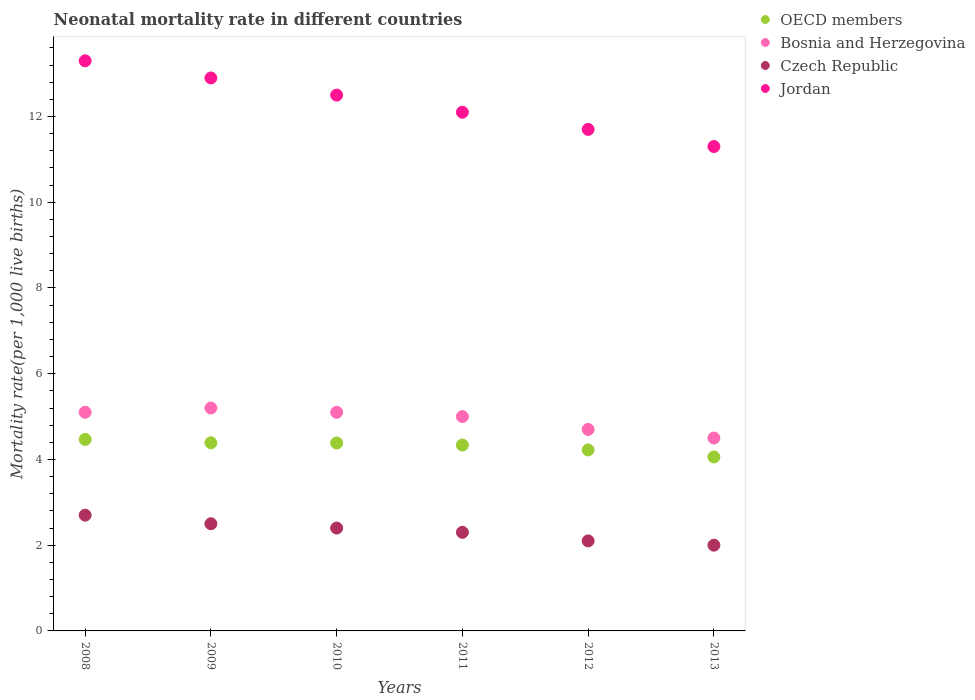How many different coloured dotlines are there?
Offer a terse response. 4. Is the number of dotlines equal to the number of legend labels?
Keep it short and to the point. Yes. What is the neonatal mortality rate in OECD members in 2009?
Offer a terse response. 4.39. Across all years, what is the maximum neonatal mortality rate in Bosnia and Herzegovina?
Ensure brevity in your answer.  5.2. In which year was the neonatal mortality rate in Jordan maximum?
Your answer should be compact. 2008. In which year was the neonatal mortality rate in Jordan minimum?
Make the answer very short. 2013. What is the total neonatal mortality rate in Jordan in the graph?
Your answer should be compact. 73.8. What is the difference between the neonatal mortality rate in Czech Republic in 2008 and that in 2012?
Ensure brevity in your answer.  0.6. What is the difference between the neonatal mortality rate in Jordan in 2011 and the neonatal mortality rate in Czech Republic in 2013?
Keep it short and to the point. 10.1. What is the average neonatal mortality rate in Jordan per year?
Offer a terse response. 12.3. In the year 2013, what is the difference between the neonatal mortality rate in OECD members and neonatal mortality rate in Czech Republic?
Provide a succinct answer. 2.06. In how many years, is the neonatal mortality rate in Czech Republic greater than 12?
Provide a succinct answer. 0. What is the ratio of the neonatal mortality rate in Jordan in 2009 to that in 2013?
Your response must be concise. 1.14. What is the difference between the highest and the second highest neonatal mortality rate in Czech Republic?
Provide a short and direct response. 0.2. In how many years, is the neonatal mortality rate in Bosnia and Herzegovina greater than the average neonatal mortality rate in Bosnia and Herzegovina taken over all years?
Give a very brief answer. 4. Is the sum of the neonatal mortality rate in Czech Republic in 2011 and 2012 greater than the maximum neonatal mortality rate in Bosnia and Herzegovina across all years?
Provide a succinct answer. No. Is it the case that in every year, the sum of the neonatal mortality rate in Bosnia and Herzegovina and neonatal mortality rate in Jordan  is greater than the neonatal mortality rate in Czech Republic?
Your answer should be compact. Yes. Does the neonatal mortality rate in Bosnia and Herzegovina monotonically increase over the years?
Offer a very short reply. No. Is the neonatal mortality rate in Bosnia and Herzegovina strictly less than the neonatal mortality rate in Jordan over the years?
Offer a very short reply. Yes. How many dotlines are there?
Provide a succinct answer. 4. How many years are there in the graph?
Your answer should be compact. 6. What is the difference between two consecutive major ticks on the Y-axis?
Keep it short and to the point. 2. Are the values on the major ticks of Y-axis written in scientific E-notation?
Your answer should be compact. No. Where does the legend appear in the graph?
Provide a succinct answer. Top right. How many legend labels are there?
Ensure brevity in your answer.  4. What is the title of the graph?
Offer a very short reply. Neonatal mortality rate in different countries. Does "Turks and Caicos Islands" appear as one of the legend labels in the graph?
Keep it short and to the point. No. What is the label or title of the Y-axis?
Make the answer very short. Mortality rate(per 1,0 live births). What is the Mortality rate(per 1,000 live births) in OECD members in 2008?
Provide a short and direct response. 4.47. What is the Mortality rate(per 1,000 live births) in Bosnia and Herzegovina in 2008?
Your answer should be compact. 5.1. What is the Mortality rate(per 1,000 live births) of OECD members in 2009?
Your response must be concise. 4.39. What is the Mortality rate(per 1,000 live births) of Bosnia and Herzegovina in 2009?
Offer a terse response. 5.2. What is the Mortality rate(per 1,000 live births) of Czech Republic in 2009?
Your answer should be very brief. 2.5. What is the Mortality rate(per 1,000 live births) in Jordan in 2009?
Keep it short and to the point. 12.9. What is the Mortality rate(per 1,000 live births) in OECD members in 2010?
Provide a short and direct response. 4.38. What is the Mortality rate(per 1,000 live births) in Bosnia and Herzegovina in 2010?
Offer a terse response. 5.1. What is the Mortality rate(per 1,000 live births) in Czech Republic in 2010?
Offer a terse response. 2.4. What is the Mortality rate(per 1,000 live births) in OECD members in 2011?
Your answer should be compact. 4.34. What is the Mortality rate(per 1,000 live births) in Czech Republic in 2011?
Your answer should be very brief. 2.3. What is the Mortality rate(per 1,000 live births) of Jordan in 2011?
Provide a succinct answer. 12.1. What is the Mortality rate(per 1,000 live births) in OECD members in 2012?
Offer a very short reply. 4.22. What is the Mortality rate(per 1,000 live births) in Bosnia and Herzegovina in 2012?
Offer a terse response. 4.7. What is the Mortality rate(per 1,000 live births) of Czech Republic in 2012?
Your answer should be very brief. 2.1. What is the Mortality rate(per 1,000 live births) of Jordan in 2012?
Provide a succinct answer. 11.7. What is the Mortality rate(per 1,000 live births) of OECD members in 2013?
Keep it short and to the point. 4.06. What is the Mortality rate(per 1,000 live births) in Bosnia and Herzegovina in 2013?
Ensure brevity in your answer.  4.5. What is the Mortality rate(per 1,000 live births) in Czech Republic in 2013?
Ensure brevity in your answer.  2. Across all years, what is the maximum Mortality rate(per 1,000 live births) in OECD members?
Your response must be concise. 4.47. Across all years, what is the minimum Mortality rate(per 1,000 live births) in OECD members?
Offer a terse response. 4.06. Across all years, what is the minimum Mortality rate(per 1,000 live births) in Bosnia and Herzegovina?
Offer a very short reply. 4.5. Across all years, what is the minimum Mortality rate(per 1,000 live births) of Czech Republic?
Offer a very short reply. 2. What is the total Mortality rate(per 1,000 live births) in OECD members in the graph?
Your answer should be very brief. 25.86. What is the total Mortality rate(per 1,000 live births) in Bosnia and Herzegovina in the graph?
Ensure brevity in your answer.  29.6. What is the total Mortality rate(per 1,000 live births) of Jordan in the graph?
Keep it short and to the point. 73.8. What is the difference between the Mortality rate(per 1,000 live births) of OECD members in 2008 and that in 2009?
Provide a succinct answer. 0.08. What is the difference between the Mortality rate(per 1,000 live births) in Bosnia and Herzegovina in 2008 and that in 2009?
Your answer should be compact. -0.1. What is the difference between the Mortality rate(per 1,000 live births) of Jordan in 2008 and that in 2009?
Give a very brief answer. 0.4. What is the difference between the Mortality rate(per 1,000 live births) of OECD members in 2008 and that in 2010?
Your answer should be very brief. 0.08. What is the difference between the Mortality rate(per 1,000 live births) in Bosnia and Herzegovina in 2008 and that in 2010?
Offer a terse response. 0. What is the difference between the Mortality rate(per 1,000 live births) in Czech Republic in 2008 and that in 2010?
Your answer should be very brief. 0.3. What is the difference between the Mortality rate(per 1,000 live births) of Jordan in 2008 and that in 2010?
Provide a succinct answer. 0.8. What is the difference between the Mortality rate(per 1,000 live births) in OECD members in 2008 and that in 2011?
Ensure brevity in your answer.  0.13. What is the difference between the Mortality rate(per 1,000 live births) in Bosnia and Herzegovina in 2008 and that in 2011?
Your response must be concise. 0.1. What is the difference between the Mortality rate(per 1,000 live births) in Czech Republic in 2008 and that in 2011?
Give a very brief answer. 0.4. What is the difference between the Mortality rate(per 1,000 live births) of OECD members in 2008 and that in 2012?
Keep it short and to the point. 0.25. What is the difference between the Mortality rate(per 1,000 live births) in Czech Republic in 2008 and that in 2012?
Your answer should be very brief. 0.6. What is the difference between the Mortality rate(per 1,000 live births) in OECD members in 2008 and that in 2013?
Make the answer very short. 0.41. What is the difference between the Mortality rate(per 1,000 live births) in Bosnia and Herzegovina in 2008 and that in 2013?
Ensure brevity in your answer.  0.6. What is the difference between the Mortality rate(per 1,000 live births) of Czech Republic in 2008 and that in 2013?
Give a very brief answer. 0.7. What is the difference between the Mortality rate(per 1,000 live births) in OECD members in 2009 and that in 2010?
Ensure brevity in your answer.  0. What is the difference between the Mortality rate(per 1,000 live births) of Jordan in 2009 and that in 2010?
Your answer should be very brief. 0.4. What is the difference between the Mortality rate(per 1,000 live births) of OECD members in 2009 and that in 2011?
Your response must be concise. 0.05. What is the difference between the Mortality rate(per 1,000 live births) of Czech Republic in 2009 and that in 2011?
Offer a terse response. 0.2. What is the difference between the Mortality rate(per 1,000 live births) of Jordan in 2009 and that in 2011?
Your answer should be very brief. 0.8. What is the difference between the Mortality rate(per 1,000 live births) of OECD members in 2009 and that in 2012?
Give a very brief answer. 0.17. What is the difference between the Mortality rate(per 1,000 live births) of Bosnia and Herzegovina in 2009 and that in 2012?
Give a very brief answer. 0.5. What is the difference between the Mortality rate(per 1,000 live births) in Jordan in 2009 and that in 2012?
Offer a very short reply. 1.2. What is the difference between the Mortality rate(per 1,000 live births) of OECD members in 2009 and that in 2013?
Give a very brief answer. 0.33. What is the difference between the Mortality rate(per 1,000 live births) in Bosnia and Herzegovina in 2009 and that in 2013?
Keep it short and to the point. 0.7. What is the difference between the Mortality rate(per 1,000 live births) in Jordan in 2009 and that in 2013?
Provide a short and direct response. 1.6. What is the difference between the Mortality rate(per 1,000 live births) of OECD members in 2010 and that in 2011?
Keep it short and to the point. 0.05. What is the difference between the Mortality rate(per 1,000 live births) of Czech Republic in 2010 and that in 2011?
Make the answer very short. 0.1. What is the difference between the Mortality rate(per 1,000 live births) in Jordan in 2010 and that in 2011?
Provide a short and direct response. 0.4. What is the difference between the Mortality rate(per 1,000 live births) of OECD members in 2010 and that in 2012?
Your response must be concise. 0.16. What is the difference between the Mortality rate(per 1,000 live births) in OECD members in 2010 and that in 2013?
Offer a very short reply. 0.33. What is the difference between the Mortality rate(per 1,000 live births) in Bosnia and Herzegovina in 2010 and that in 2013?
Provide a short and direct response. 0.6. What is the difference between the Mortality rate(per 1,000 live births) of Jordan in 2010 and that in 2013?
Your response must be concise. 1.2. What is the difference between the Mortality rate(per 1,000 live births) in OECD members in 2011 and that in 2012?
Offer a very short reply. 0.11. What is the difference between the Mortality rate(per 1,000 live births) in Czech Republic in 2011 and that in 2012?
Your response must be concise. 0.2. What is the difference between the Mortality rate(per 1,000 live births) of Jordan in 2011 and that in 2012?
Your answer should be compact. 0.4. What is the difference between the Mortality rate(per 1,000 live births) in OECD members in 2011 and that in 2013?
Make the answer very short. 0.28. What is the difference between the Mortality rate(per 1,000 live births) in OECD members in 2012 and that in 2013?
Your answer should be compact. 0.16. What is the difference between the Mortality rate(per 1,000 live births) in Czech Republic in 2012 and that in 2013?
Keep it short and to the point. 0.1. What is the difference between the Mortality rate(per 1,000 live births) in OECD members in 2008 and the Mortality rate(per 1,000 live births) in Bosnia and Herzegovina in 2009?
Ensure brevity in your answer.  -0.73. What is the difference between the Mortality rate(per 1,000 live births) of OECD members in 2008 and the Mortality rate(per 1,000 live births) of Czech Republic in 2009?
Your answer should be compact. 1.97. What is the difference between the Mortality rate(per 1,000 live births) of OECD members in 2008 and the Mortality rate(per 1,000 live births) of Jordan in 2009?
Keep it short and to the point. -8.43. What is the difference between the Mortality rate(per 1,000 live births) in Bosnia and Herzegovina in 2008 and the Mortality rate(per 1,000 live births) in Czech Republic in 2009?
Offer a very short reply. 2.6. What is the difference between the Mortality rate(per 1,000 live births) in OECD members in 2008 and the Mortality rate(per 1,000 live births) in Bosnia and Herzegovina in 2010?
Give a very brief answer. -0.63. What is the difference between the Mortality rate(per 1,000 live births) of OECD members in 2008 and the Mortality rate(per 1,000 live births) of Czech Republic in 2010?
Your response must be concise. 2.07. What is the difference between the Mortality rate(per 1,000 live births) of OECD members in 2008 and the Mortality rate(per 1,000 live births) of Jordan in 2010?
Offer a very short reply. -8.03. What is the difference between the Mortality rate(per 1,000 live births) in Bosnia and Herzegovina in 2008 and the Mortality rate(per 1,000 live births) in Jordan in 2010?
Provide a short and direct response. -7.4. What is the difference between the Mortality rate(per 1,000 live births) of Czech Republic in 2008 and the Mortality rate(per 1,000 live births) of Jordan in 2010?
Ensure brevity in your answer.  -9.8. What is the difference between the Mortality rate(per 1,000 live births) of OECD members in 2008 and the Mortality rate(per 1,000 live births) of Bosnia and Herzegovina in 2011?
Provide a succinct answer. -0.53. What is the difference between the Mortality rate(per 1,000 live births) of OECD members in 2008 and the Mortality rate(per 1,000 live births) of Czech Republic in 2011?
Your response must be concise. 2.17. What is the difference between the Mortality rate(per 1,000 live births) in OECD members in 2008 and the Mortality rate(per 1,000 live births) in Jordan in 2011?
Provide a succinct answer. -7.63. What is the difference between the Mortality rate(per 1,000 live births) in OECD members in 2008 and the Mortality rate(per 1,000 live births) in Bosnia and Herzegovina in 2012?
Offer a terse response. -0.23. What is the difference between the Mortality rate(per 1,000 live births) of OECD members in 2008 and the Mortality rate(per 1,000 live births) of Czech Republic in 2012?
Your answer should be compact. 2.37. What is the difference between the Mortality rate(per 1,000 live births) of OECD members in 2008 and the Mortality rate(per 1,000 live births) of Jordan in 2012?
Provide a succinct answer. -7.23. What is the difference between the Mortality rate(per 1,000 live births) in Bosnia and Herzegovina in 2008 and the Mortality rate(per 1,000 live births) in Czech Republic in 2012?
Make the answer very short. 3. What is the difference between the Mortality rate(per 1,000 live births) in Czech Republic in 2008 and the Mortality rate(per 1,000 live births) in Jordan in 2012?
Ensure brevity in your answer.  -9. What is the difference between the Mortality rate(per 1,000 live births) in OECD members in 2008 and the Mortality rate(per 1,000 live births) in Bosnia and Herzegovina in 2013?
Keep it short and to the point. -0.03. What is the difference between the Mortality rate(per 1,000 live births) in OECD members in 2008 and the Mortality rate(per 1,000 live births) in Czech Republic in 2013?
Your answer should be compact. 2.47. What is the difference between the Mortality rate(per 1,000 live births) in OECD members in 2008 and the Mortality rate(per 1,000 live births) in Jordan in 2013?
Provide a succinct answer. -6.83. What is the difference between the Mortality rate(per 1,000 live births) in Bosnia and Herzegovina in 2008 and the Mortality rate(per 1,000 live births) in Jordan in 2013?
Keep it short and to the point. -6.2. What is the difference between the Mortality rate(per 1,000 live births) in Czech Republic in 2008 and the Mortality rate(per 1,000 live births) in Jordan in 2013?
Make the answer very short. -8.6. What is the difference between the Mortality rate(per 1,000 live births) of OECD members in 2009 and the Mortality rate(per 1,000 live births) of Bosnia and Herzegovina in 2010?
Keep it short and to the point. -0.71. What is the difference between the Mortality rate(per 1,000 live births) in OECD members in 2009 and the Mortality rate(per 1,000 live births) in Czech Republic in 2010?
Provide a short and direct response. 1.99. What is the difference between the Mortality rate(per 1,000 live births) of OECD members in 2009 and the Mortality rate(per 1,000 live births) of Jordan in 2010?
Keep it short and to the point. -8.11. What is the difference between the Mortality rate(per 1,000 live births) of OECD members in 2009 and the Mortality rate(per 1,000 live births) of Bosnia and Herzegovina in 2011?
Ensure brevity in your answer.  -0.61. What is the difference between the Mortality rate(per 1,000 live births) in OECD members in 2009 and the Mortality rate(per 1,000 live births) in Czech Republic in 2011?
Offer a very short reply. 2.09. What is the difference between the Mortality rate(per 1,000 live births) in OECD members in 2009 and the Mortality rate(per 1,000 live births) in Jordan in 2011?
Keep it short and to the point. -7.71. What is the difference between the Mortality rate(per 1,000 live births) of Czech Republic in 2009 and the Mortality rate(per 1,000 live births) of Jordan in 2011?
Make the answer very short. -9.6. What is the difference between the Mortality rate(per 1,000 live births) of OECD members in 2009 and the Mortality rate(per 1,000 live births) of Bosnia and Herzegovina in 2012?
Provide a succinct answer. -0.31. What is the difference between the Mortality rate(per 1,000 live births) in OECD members in 2009 and the Mortality rate(per 1,000 live births) in Czech Republic in 2012?
Your answer should be very brief. 2.29. What is the difference between the Mortality rate(per 1,000 live births) of OECD members in 2009 and the Mortality rate(per 1,000 live births) of Jordan in 2012?
Ensure brevity in your answer.  -7.31. What is the difference between the Mortality rate(per 1,000 live births) in Bosnia and Herzegovina in 2009 and the Mortality rate(per 1,000 live births) in Jordan in 2012?
Provide a short and direct response. -6.5. What is the difference between the Mortality rate(per 1,000 live births) in OECD members in 2009 and the Mortality rate(per 1,000 live births) in Bosnia and Herzegovina in 2013?
Make the answer very short. -0.11. What is the difference between the Mortality rate(per 1,000 live births) of OECD members in 2009 and the Mortality rate(per 1,000 live births) of Czech Republic in 2013?
Provide a succinct answer. 2.39. What is the difference between the Mortality rate(per 1,000 live births) of OECD members in 2009 and the Mortality rate(per 1,000 live births) of Jordan in 2013?
Make the answer very short. -6.91. What is the difference between the Mortality rate(per 1,000 live births) of OECD members in 2010 and the Mortality rate(per 1,000 live births) of Bosnia and Herzegovina in 2011?
Your answer should be compact. -0.62. What is the difference between the Mortality rate(per 1,000 live births) of OECD members in 2010 and the Mortality rate(per 1,000 live births) of Czech Republic in 2011?
Make the answer very short. 2.08. What is the difference between the Mortality rate(per 1,000 live births) of OECD members in 2010 and the Mortality rate(per 1,000 live births) of Jordan in 2011?
Provide a succinct answer. -7.72. What is the difference between the Mortality rate(per 1,000 live births) of Bosnia and Herzegovina in 2010 and the Mortality rate(per 1,000 live births) of Jordan in 2011?
Offer a very short reply. -7. What is the difference between the Mortality rate(per 1,000 live births) of Czech Republic in 2010 and the Mortality rate(per 1,000 live births) of Jordan in 2011?
Ensure brevity in your answer.  -9.7. What is the difference between the Mortality rate(per 1,000 live births) in OECD members in 2010 and the Mortality rate(per 1,000 live births) in Bosnia and Herzegovina in 2012?
Give a very brief answer. -0.32. What is the difference between the Mortality rate(per 1,000 live births) in OECD members in 2010 and the Mortality rate(per 1,000 live births) in Czech Republic in 2012?
Your answer should be compact. 2.28. What is the difference between the Mortality rate(per 1,000 live births) of OECD members in 2010 and the Mortality rate(per 1,000 live births) of Jordan in 2012?
Give a very brief answer. -7.32. What is the difference between the Mortality rate(per 1,000 live births) in Bosnia and Herzegovina in 2010 and the Mortality rate(per 1,000 live births) in Czech Republic in 2012?
Offer a very short reply. 3. What is the difference between the Mortality rate(per 1,000 live births) of Bosnia and Herzegovina in 2010 and the Mortality rate(per 1,000 live births) of Jordan in 2012?
Provide a short and direct response. -6.6. What is the difference between the Mortality rate(per 1,000 live births) in Czech Republic in 2010 and the Mortality rate(per 1,000 live births) in Jordan in 2012?
Your answer should be compact. -9.3. What is the difference between the Mortality rate(per 1,000 live births) of OECD members in 2010 and the Mortality rate(per 1,000 live births) of Bosnia and Herzegovina in 2013?
Offer a very short reply. -0.12. What is the difference between the Mortality rate(per 1,000 live births) in OECD members in 2010 and the Mortality rate(per 1,000 live births) in Czech Republic in 2013?
Provide a short and direct response. 2.38. What is the difference between the Mortality rate(per 1,000 live births) of OECD members in 2010 and the Mortality rate(per 1,000 live births) of Jordan in 2013?
Your response must be concise. -6.92. What is the difference between the Mortality rate(per 1,000 live births) of Bosnia and Herzegovina in 2010 and the Mortality rate(per 1,000 live births) of Czech Republic in 2013?
Your answer should be compact. 3.1. What is the difference between the Mortality rate(per 1,000 live births) in Bosnia and Herzegovina in 2010 and the Mortality rate(per 1,000 live births) in Jordan in 2013?
Your response must be concise. -6.2. What is the difference between the Mortality rate(per 1,000 live births) of Czech Republic in 2010 and the Mortality rate(per 1,000 live births) of Jordan in 2013?
Keep it short and to the point. -8.9. What is the difference between the Mortality rate(per 1,000 live births) in OECD members in 2011 and the Mortality rate(per 1,000 live births) in Bosnia and Herzegovina in 2012?
Give a very brief answer. -0.36. What is the difference between the Mortality rate(per 1,000 live births) of OECD members in 2011 and the Mortality rate(per 1,000 live births) of Czech Republic in 2012?
Offer a very short reply. 2.24. What is the difference between the Mortality rate(per 1,000 live births) in OECD members in 2011 and the Mortality rate(per 1,000 live births) in Jordan in 2012?
Ensure brevity in your answer.  -7.36. What is the difference between the Mortality rate(per 1,000 live births) in OECD members in 2011 and the Mortality rate(per 1,000 live births) in Bosnia and Herzegovina in 2013?
Offer a very short reply. -0.16. What is the difference between the Mortality rate(per 1,000 live births) in OECD members in 2011 and the Mortality rate(per 1,000 live births) in Czech Republic in 2013?
Your response must be concise. 2.34. What is the difference between the Mortality rate(per 1,000 live births) of OECD members in 2011 and the Mortality rate(per 1,000 live births) of Jordan in 2013?
Offer a very short reply. -6.96. What is the difference between the Mortality rate(per 1,000 live births) of Bosnia and Herzegovina in 2011 and the Mortality rate(per 1,000 live births) of Jordan in 2013?
Provide a succinct answer. -6.3. What is the difference between the Mortality rate(per 1,000 live births) in Czech Republic in 2011 and the Mortality rate(per 1,000 live births) in Jordan in 2013?
Ensure brevity in your answer.  -9. What is the difference between the Mortality rate(per 1,000 live births) in OECD members in 2012 and the Mortality rate(per 1,000 live births) in Bosnia and Herzegovina in 2013?
Keep it short and to the point. -0.28. What is the difference between the Mortality rate(per 1,000 live births) of OECD members in 2012 and the Mortality rate(per 1,000 live births) of Czech Republic in 2013?
Ensure brevity in your answer.  2.22. What is the difference between the Mortality rate(per 1,000 live births) in OECD members in 2012 and the Mortality rate(per 1,000 live births) in Jordan in 2013?
Your answer should be very brief. -7.08. What is the difference between the Mortality rate(per 1,000 live births) of Bosnia and Herzegovina in 2012 and the Mortality rate(per 1,000 live births) of Czech Republic in 2013?
Your answer should be compact. 2.7. What is the difference between the Mortality rate(per 1,000 live births) of Czech Republic in 2012 and the Mortality rate(per 1,000 live births) of Jordan in 2013?
Make the answer very short. -9.2. What is the average Mortality rate(per 1,000 live births) in OECD members per year?
Ensure brevity in your answer.  4.31. What is the average Mortality rate(per 1,000 live births) in Bosnia and Herzegovina per year?
Your response must be concise. 4.93. What is the average Mortality rate(per 1,000 live births) in Czech Republic per year?
Your response must be concise. 2.33. In the year 2008, what is the difference between the Mortality rate(per 1,000 live births) in OECD members and Mortality rate(per 1,000 live births) in Bosnia and Herzegovina?
Offer a terse response. -0.63. In the year 2008, what is the difference between the Mortality rate(per 1,000 live births) in OECD members and Mortality rate(per 1,000 live births) in Czech Republic?
Make the answer very short. 1.77. In the year 2008, what is the difference between the Mortality rate(per 1,000 live births) of OECD members and Mortality rate(per 1,000 live births) of Jordan?
Provide a succinct answer. -8.83. In the year 2008, what is the difference between the Mortality rate(per 1,000 live births) in Bosnia and Herzegovina and Mortality rate(per 1,000 live births) in Czech Republic?
Ensure brevity in your answer.  2.4. In the year 2009, what is the difference between the Mortality rate(per 1,000 live births) of OECD members and Mortality rate(per 1,000 live births) of Bosnia and Herzegovina?
Your answer should be compact. -0.81. In the year 2009, what is the difference between the Mortality rate(per 1,000 live births) in OECD members and Mortality rate(per 1,000 live births) in Czech Republic?
Your answer should be very brief. 1.89. In the year 2009, what is the difference between the Mortality rate(per 1,000 live births) of OECD members and Mortality rate(per 1,000 live births) of Jordan?
Provide a succinct answer. -8.51. In the year 2009, what is the difference between the Mortality rate(per 1,000 live births) in Bosnia and Herzegovina and Mortality rate(per 1,000 live births) in Czech Republic?
Ensure brevity in your answer.  2.7. In the year 2009, what is the difference between the Mortality rate(per 1,000 live births) of Bosnia and Herzegovina and Mortality rate(per 1,000 live births) of Jordan?
Ensure brevity in your answer.  -7.7. In the year 2009, what is the difference between the Mortality rate(per 1,000 live births) in Czech Republic and Mortality rate(per 1,000 live births) in Jordan?
Keep it short and to the point. -10.4. In the year 2010, what is the difference between the Mortality rate(per 1,000 live births) of OECD members and Mortality rate(per 1,000 live births) of Bosnia and Herzegovina?
Provide a succinct answer. -0.72. In the year 2010, what is the difference between the Mortality rate(per 1,000 live births) of OECD members and Mortality rate(per 1,000 live births) of Czech Republic?
Provide a succinct answer. 1.98. In the year 2010, what is the difference between the Mortality rate(per 1,000 live births) in OECD members and Mortality rate(per 1,000 live births) in Jordan?
Offer a terse response. -8.12. In the year 2010, what is the difference between the Mortality rate(per 1,000 live births) in Bosnia and Herzegovina and Mortality rate(per 1,000 live births) in Czech Republic?
Provide a succinct answer. 2.7. In the year 2010, what is the difference between the Mortality rate(per 1,000 live births) in Bosnia and Herzegovina and Mortality rate(per 1,000 live births) in Jordan?
Your response must be concise. -7.4. In the year 2011, what is the difference between the Mortality rate(per 1,000 live births) in OECD members and Mortality rate(per 1,000 live births) in Bosnia and Herzegovina?
Give a very brief answer. -0.66. In the year 2011, what is the difference between the Mortality rate(per 1,000 live births) in OECD members and Mortality rate(per 1,000 live births) in Czech Republic?
Give a very brief answer. 2.04. In the year 2011, what is the difference between the Mortality rate(per 1,000 live births) in OECD members and Mortality rate(per 1,000 live births) in Jordan?
Provide a short and direct response. -7.76. In the year 2011, what is the difference between the Mortality rate(per 1,000 live births) of Bosnia and Herzegovina and Mortality rate(per 1,000 live births) of Czech Republic?
Keep it short and to the point. 2.7. In the year 2012, what is the difference between the Mortality rate(per 1,000 live births) in OECD members and Mortality rate(per 1,000 live births) in Bosnia and Herzegovina?
Provide a succinct answer. -0.48. In the year 2012, what is the difference between the Mortality rate(per 1,000 live births) in OECD members and Mortality rate(per 1,000 live births) in Czech Republic?
Ensure brevity in your answer.  2.12. In the year 2012, what is the difference between the Mortality rate(per 1,000 live births) in OECD members and Mortality rate(per 1,000 live births) in Jordan?
Ensure brevity in your answer.  -7.48. In the year 2012, what is the difference between the Mortality rate(per 1,000 live births) of Bosnia and Herzegovina and Mortality rate(per 1,000 live births) of Czech Republic?
Ensure brevity in your answer.  2.6. In the year 2012, what is the difference between the Mortality rate(per 1,000 live births) in Bosnia and Herzegovina and Mortality rate(per 1,000 live births) in Jordan?
Your answer should be compact. -7. In the year 2013, what is the difference between the Mortality rate(per 1,000 live births) of OECD members and Mortality rate(per 1,000 live births) of Bosnia and Herzegovina?
Make the answer very short. -0.44. In the year 2013, what is the difference between the Mortality rate(per 1,000 live births) in OECD members and Mortality rate(per 1,000 live births) in Czech Republic?
Keep it short and to the point. 2.06. In the year 2013, what is the difference between the Mortality rate(per 1,000 live births) of OECD members and Mortality rate(per 1,000 live births) of Jordan?
Offer a terse response. -7.24. What is the ratio of the Mortality rate(per 1,000 live births) in OECD members in 2008 to that in 2009?
Offer a terse response. 1.02. What is the ratio of the Mortality rate(per 1,000 live births) of Bosnia and Herzegovina in 2008 to that in 2009?
Ensure brevity in your answer.  0.98. What is the ratio of the Mortality rate(per 1,000 live births) of Czech Republic in 2008 to that in 2009?
Ensure brevity in your answer.  1.08. What is the ratio of the Mortality rate(per 1,000 live births) of Jordan in 2008 to that in 2009?
Make the answer very short. 1.03. What is the ratio of the Mortality rate(per 1,000 live births) in Czech Republic in 2008 to that in 2010?
Your response must be concise. 1.12. What is the ratio of the Mortality rate(per 1,000 live births) of Jordan in 2008 to that in 2010?
Provide a short and direct response. 1.06. What is the ratio of the Mortality rate(per 1,000 live births) in OECD members in 2008 to that in 2011?
Your answer should be compact. 1.03. What is the ratio of the Mortality rate(per 1,000 live births) of Czech Republic in 2008 to that in 2011?
Your response must be concise. 1.17. What is the ratio of the Mortality rate(per 1,000 live births) of Jordan in 2008 to that in 2011?
Provide a short and direct response. 1.1. What is the ratio of the Mortality rate(per 1,000 live births) in OECD members in 2008 to that in 2012?
Your answer should be very brief. 1.06. What is the ratio of the Mortality rate(per 1,000 live births) in Bosnia and Herzegovina in 2008 to that in 2012?
Ensure brevity in your answer.  1.09. What is the ratio of the Mortality rate(per 1,000 live births) of Jordan in 2008 to that in 2012?
Provide a succinct answer. 1.14. What is the ratio of the Mortality rate(per 1,000 live births) of OECD members in 2008 to that in 2013?
Provide a succinct answer. 1.1. What is the ratio of the Mortality rate(per 1,000 live births) of Bosnia and Herzegovina in 2008 to that in 2013?
Your response must be concise. 1.13. What is the ratio of the Mortality rate(per 1,000 live births) of Czech Republic in 2008 to that in 2013?
Your answer should be very brief. 1.35. What is the ratio of the Mortality rate(per 1,000 live births) in Jordan in 2008 to that in 2013?
Offer a terse response. 1.18. What is the ratio of the Mortality rate(per 1,000 live births) in OECD members in 2009 to that in 2010?
Provide a short and direct response. 1. What is the ratio of the Mortality rate(per 1,000 live births) of Bosnia and Herzegovina in 2009 to that in 2010?
Give a very brief answer. 1.02. What is the ratio of the Mortality rate(per 1,000 live births) in Czech Republic in 2009 to that in 2010?
Your answer should be compact. 1.04. What is the ratio of the Mortality rate(per 1,000 live births) in Jordan in 2009 to that in 2010?
Offer a very short reply. 1.03. What is the ratio of the Mortality rate(per 1,000 live births) in OECD members in 2009 to that in 2011?
Keep it short and to the point. 1.01. What is the ratio of the Mortality rate(per 1,000 live births) of Czech Republic in 2009 to that in 2011?
Offer a terse response. 1.09. What is the ratio of the Mortality rate(per 1,000 live births) in Jordan in 2009 to that in 2011?
Offer a terse response. 1.07. What is the ratio of the Mortality rate(per 1,000 live births) in OECD members in 2009 to that in 2012?
Your answer should be compact. 1.04. What is the ratio of the Mortality rate(per 1,000 live births) of Bosnia and Herzegovina in 2009 to that in 2012?
Offer a very short reply. 1.11. What is the ratio of the Mortality rate(per 1,000 live births) of Czech Republic in 2009 to that in 2012?
Offer a terse response. 1.19. What is the ratio of the Mortality rate(per 1,000 live births) of Jordan in 2009 to that in 2012?
Provide a succinct answer. 1.1. What is the ratio of the Mortality rate(per 1,000 live births) of OECD members in 2009 to that in 2013?
Make the answer very short. 1.08. What is the ratio of the Mortality rate(per 1,000 live births) of Bosnia and Herzegovina in 2009 to that in 2013?
Offer a terse response. 1.16. What is the ratio of the Mortality rate(per 1,000 live births) in Jordan in 2009 to that in 2013?
Your response must be concise. 1.14. What is the ratio of the Mortality rate(per 1,000 live births) in OECD members in 2010 to that in 2011?
Your answer should be very brief. 1.01. What is the ratio of the Mortality rate(per 1,000 live births) in Bosnia and Herzegovina in 2010 to that in 2011?
Give a very brief answer. 1.02. What is the ratio of the Mortality rate(per 1,000 live births) of Czech Republic in 2010 to that in 2011?
Provide a short and direct response. 1.04. What is the ratio of the Mortality rate(per 1,000 live births) in Jordan in 2010 to that in 2011?
Ensure brevity in your answer.  1.03. What is the ratio of the Mortality rate(per 1,000 live births) in OECD members in 2010 to that in 2012?
Provide a short and direct response. 1.04. What is the ratio of the Mortality rate(per 1,000 live births) in Bosnia and Herzegovina in 2010 to that in 2012?
Your response must be concise. 1.09. What is the ratio of the Mortality rate(per 1,000 live births) of Jordan in 2010 to that in 2012?
Provide a succinct answer. 1.07. What is the ratio of the Mortality rate(per 1,000 live births) in OECD members in 2010 to that in 2013?
Give a very brief answer. 1.08. What is the ratio of the Mortality rate(per 1,000 live births) in Bosnia and Herzegovina in 2010 to that in 2013?
Give a very brief answer. 1.13. What is the ratio of the Mortality rate(per 1,000 live births) in Jordan in 2010 to that in 2013?
Provide a short and direct response. 1.11. What is the ratio of the Mortality rate(per 1,000 live births) of OECD members in 2011 to that in 2012?
Provide a succinct answer. 1.03. What is the ratio of the Mortality rate(per 1,000 live births) in Bosnia and Herzegovina in 2011 to that in 2012?
Keep it short and to the point. 1.06. What is the ratio of the Mortality rate(per 1,000 live births) in Czech Republic in 2011 to that in 2012?
Provide a short and direct response. 1.1. What is the ratio of the Mortality rate(per 1,000 live births) in Jordan in 2011 to that in 2012?
Give a very brief answer. 1.03. What is the ratio of the Mortality rate(per 1,000 live births) of OECD members in 2011 to that in 2013?
Your response must be concise. 1.07. What is the ratio of the Mortality rate(per 1,000 live births) in Bosnia and Herzegovina in 2011 to that in 2013?
Provide a succinct answer. 1.11. What is the ratio of the Mortality rate(per 1,000 live births) of Czech Republic in 2011 to that in 2013?
Your response must be concise. 1.15. What is the ratio of the Mortality rate(per 1,000 live births) in Jordan in 2011 to that in 2013?
Your answer should be compact. 1.07. What is the ratio of the Mortality rate(per 1,000 live births) of OECD members in 2012 to that in 2013?
Make the answer very short. 1.04. What is the ratio of the Mortality rate(per 1,000 live births) in Bosnia and Herzegovina in 2012 to that in 2013?
Make the answer very short. 1.04. What is the ratio of the Mortality rate(per 1,000 live births) in Czech Republic in 2012 to that in 2013?
Your answer should be compact. 1.05. What is the ratio of the Mortality rate(per 1,000 live births) in Jordan in 2012 to that in 2013?
Provide a short and direct response. 1.04. What is the difference between the highest and the second highest Mortality rate(per 1,000 live births) of OECD members?
Make the answer very short. 0.08. What is the difference between the highest and the second highest Mortality rate(per 1,000 live births) in Czech Republic?
Your answer should be compact. 0.2. What is the difference between the highest and the lowest Mortality rate(per 1,000 live births) in OECD members?
Offer a very short reply. 0.41. What is the difference between the highest and the lowest Mortality rate(per 1,000 live births) in Bosnia and Herzegovina?
Offer a terse response. 0.7. What is the difference between the highest and the lowest Mortality rate(per 1,000 live births) in Jordan?
Your response must be concise. 2. 